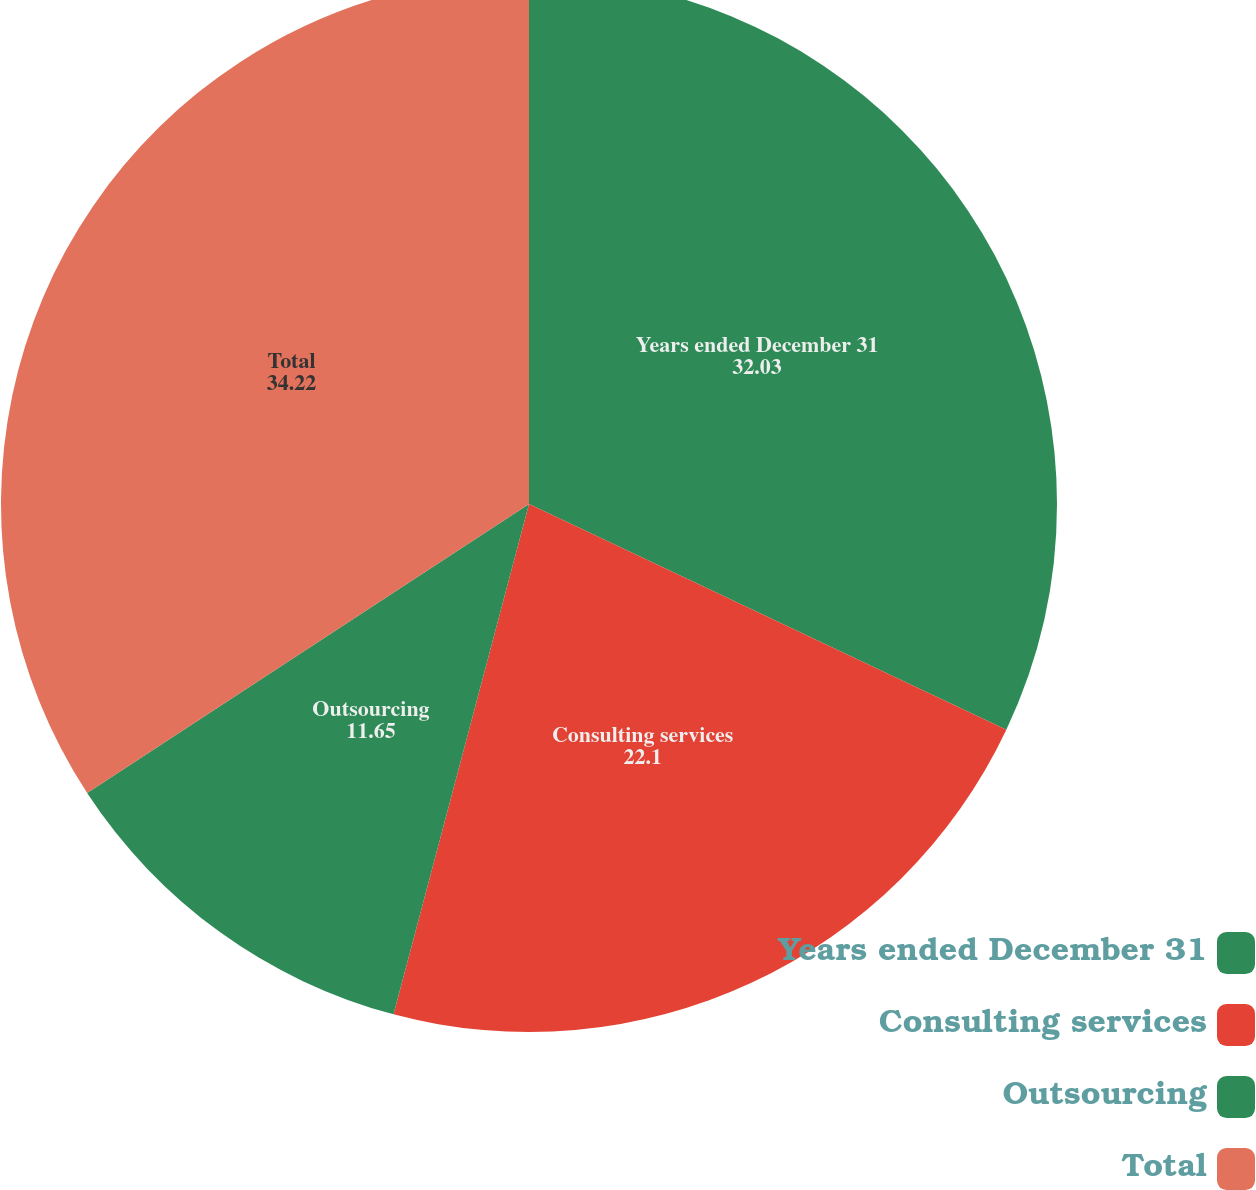<chart> <loc_0><loc_0><loc_500><loc_500><pie_chart><fcel>Years ended December 31<fcel>Consulting services<fcel>Outsourcing<fcel>Total<nl><fcel>32.03%<fcel>22.1%<fcel>11.65%<fcel>34.22%<nl></chart> 